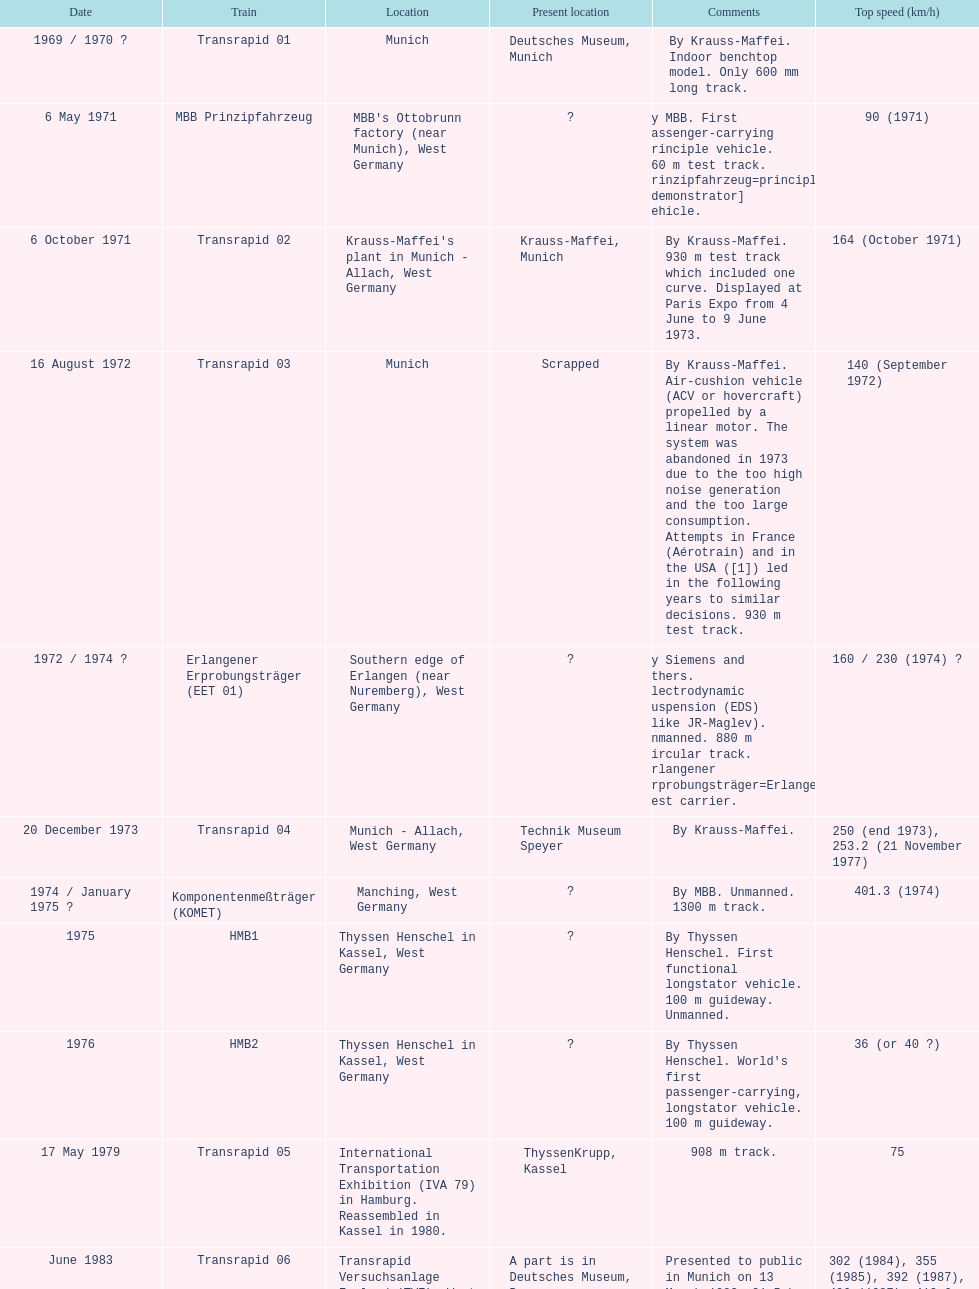What train was abandoned as a result of generating excessive noise and having an overly large consumption? Transrapid 03. 